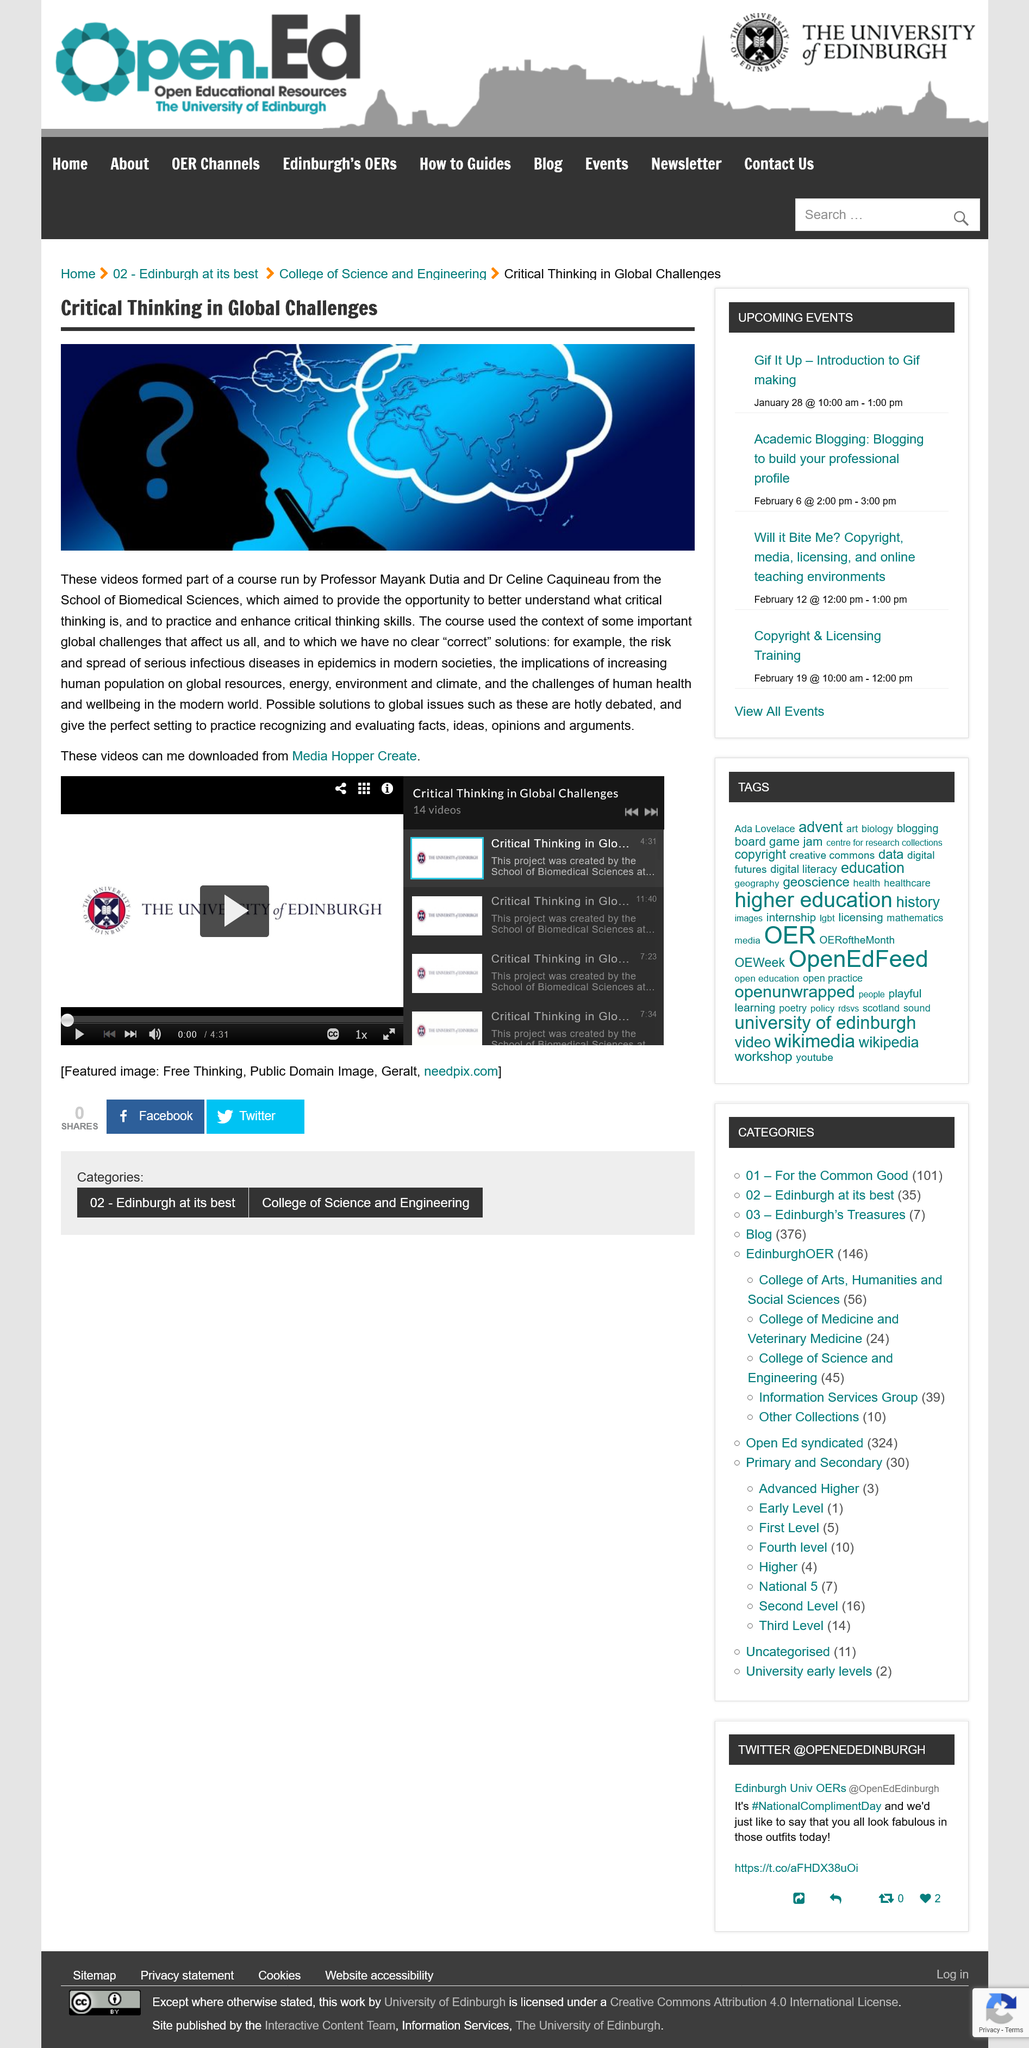Specify some key components in this picture. The videos created by Professor Dutia and Dr. Caquineau include "The Risk and Spread of Infectious Diseases" and "The Implications of Increasing Populations on Global Resources. The videos were created as part of a course. Mayank Dutia and Celine Caquineau created a variety of critical thinking videos, which can be downloaded from Media Hopper Create. 